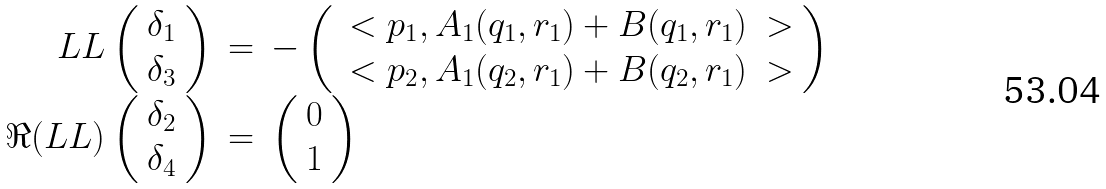<formula> <loc_0><loc_0><loc_500><loc_500>\begin{array} { r c l } L L \left ( \begin{array} { c } \delta _ { 1 } \\ \delta _ { 3 } \end{array} \right ) & = & - \left ( \begin{array} { c } \ < p _ { 1 } , A _ { 1 } ( q _ { 1 } , r _ { 1 } ) + B ( q _ { 1 } , r _ { 1 } ) \ > \\ \ < p _ { 2 } , A _ { 1 } ( q _ { 2 } , r _ { 1 } ) + B ( q _ { 2 } , r _ { 1 } ) \ > \end{array} \right ) \\ \Re ( L L ) \left ( \begin{array} { c } \delta _ { 2 } \\ \delta _ { 4 } \end{array} \right ) & = & \left ( \begin{array} { c } 0 \\ 1 \end{array} \right ) \end{array}</formula> 